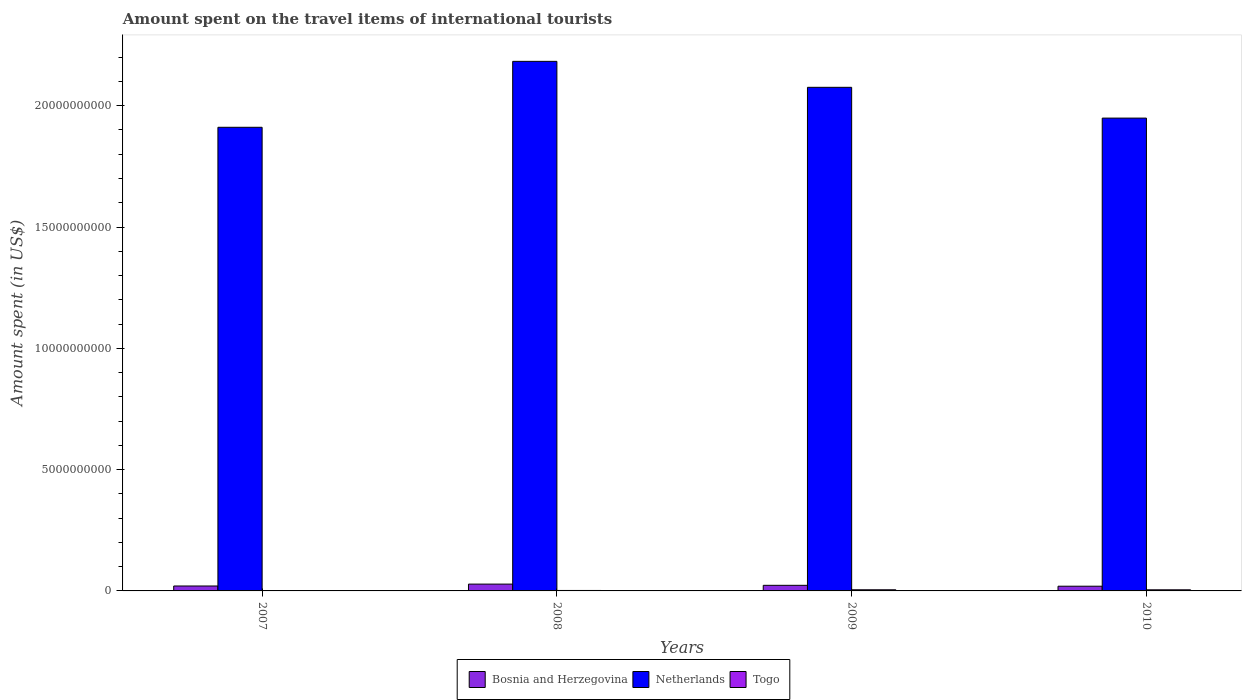How many different coloured bars are there?
Offer a terse response. 3. How many groups of bars are there?
Your answer should be compact. 4. Are the number of bars per tick equal to the number of legend labels?
Your answer should be compact. Yes. Are the number of bars on each tick of the X-axis equal?
Provide a short and direct response. Yes. How many bars are there on the 2nd tick from the right?
Make the answer very short. 3. What is the label of the 2nd group of bars from the left?
Your answer should be very brief. 2008. What is the amount spent on the travel items of international tourists in Bosnia and Herzegovina in 2008?
Your answer should be compact. 2.81e+08. Across all years, what is the maximum amount spent on the travel items of international tourists in Netherlands?
Your response must be concise. 2.18e+1. Across all years, what is the minimum amount spent on the travel items of international tourists in Netherlands?
Provide a succinct answer. 1.91e+1. In which year was the amount spent on the travel items of international tourists in Netherlands maximum?
Offer a very short reply. 2008. What is the total amount spent on the travel items of international tourists in Netherlands in the graph?
Offer a very short reply. 8.12e+1. What is the difference between the amount spent on the travel items of international tourists in Netherlands in 2007 and that in 2009?
Your answer should be very brief. -1.65e+09. What is the difference between the amount spent on the travel items of international tourists in Netherlands in 2007 and the amount spent on the travel items of international tourists in Bosnia and Herzegovina in 2010?
Offer a very short reply. 1.89e+1. What is the average amount spent on the travel items of international tourists in Bosnia and Herzegovina per year?
Provide a succinct answer. 2.27e+08. In the year 2010, what is the difference between the amount spent on the travel items of international tourists in Togo and amount spent on the travel items of international tourists in Netherlands?
Offer a terse response. -1.94e+1. What is the ratio of the amount spent on the travel items of international tourists in Togo in 2009 to that in 2010?
Provide a short and direct response. 1.02. Is the difference between the amount spent on the travel items of international tourists in Togo in 2007 and 2009 greater than the difference between the amount spent on the travel items of international tourists in Netherlands in 2007 and 2009?
Your answer should be very brief. Yes. What is the difference between the highest and the second highest amount spent on the travel items of international tourists in Netherlands?
Offer a terse response. 1.07e+09. What is the difference between the highest and the lowest amount spent on the travel items of international tourists in Bosnia and Herzegovina?
Offer a terse response. 8.70e+07. What does the 3rd bar from the left in 2010 represents?
Your answer should be compact. Togo. What does the 1st bar from the right in 2008 represents?
Offer a terse response. Togo. Is it the case that in every year, the sum of the amount spent on the travel items of international tourists in Togo and amount spent on the travel items of international tourists in Bosnia and Herzegovina is greater than the amount spent on the travel items of international tourists in Netherlands?
Ensure brevity in your answer.  No. How many bars are there?
Give a very brief answer. 12. Are all the bars in the graph horizontal?
Make the answer very short. No. What is the difference between two consecutive major ticks on the Y-axis?
Make the answer very short. 5.00e+09. Where does the legend appear in the graph?
Give a very brief answer. Bottom center. How many legend labels are there?
Provide a succinct answer. 3. How are the legend labels stacked?
Offer a terse response. Horizontal. What is the title of the graph?
Ensure brevity in your answer.  Amount spent on the travel items of international tourists. Does "Vanuatu" appear as one of the legend labels in the graph?
Ensure brevity in your answer.  No. What is the label or title of the Y-axis?
Offer a terse response. Amount spent (in US$). What is the Amount spent (in US$) in Bosnia and Herzegovina in 2007?
Make the answer very short. 2.03e+08. What is the Amount spent (in US$) of Netherlands in 2007?
Your answer should be compact. 1.91e+1. What is the Amount spent (in US$) of Togo in 2007?
Make the answer very short. 1.70e+07. What is the Amount spent (in US$) of Bosnia and Herzegovina in 2008?
Ensure brevity in your answer.  2.81e+08. What is the Amount spent (in US$) in Netherlands in 2008?
Provide a short and direct response. 2.18e+1. What is the Amount spent (in US$) of Togo in 2008?
Offer a very short reply. 1.90e+07. What is the Amount spent (in US$) in Bosnia and Herzegovina in 2009?
Your response must be concise. 2.31e+08. What is the Amount spent (in US$) in Netherlands in 2009?
Your answer should be very brief. 2.08e+1. What is the Amount spent (in US$) in Togo in 2009?
Keep it short and to the point. 4.70e+07. What is the Amount spent (in US$) in Bosnia and Herzegovina in 2010?
Your response must be concise. 1.94e+08. What is the Amount spent (in US$) in Netherlands in 2010?
Keep it short and to the point. 1.95e+1. What is the Amount spent (in US$) in Togo in 2010?
Give a very brief answer. 4.60e+07. Across all years, what is the maximum Amount spent (in US$) in Bosnia and Herzegovina?
Your response must be concise. 2.81e+08. Across all years, what is the maximum Amount spent (in US$) of Netherlands?
Offer a terse response. 2.18e+1. Across all years, what is the maximum Amount spent (in US$) of Togo?
Give a very brief answer. 4.70e+07. Across all years, what is the minimum Amount spent (in US$) of Bosnia and Herzegovina?
Your answer should be very brief. 1.94e+08. Across all years, what is the minimum Amount spent (in US$) in Netherlands?
Your answer should be compact. 1.91e+1. Across all years, what is the minimum Amount spent (in US$) of Togo?
Your answer should be very brief. 1.70e+07. What is the total Amount spent (in US$) in Bosnia and Herzegovina in the graph?
Ensure brevity in your answer.  9.09e+08. What is the total Amount spent (in US$) of Netherlands in the graph?
Offer a very short reply. 8.12e+1. What is the total Amount spent (in US$) of Togo in the graph?
Offer a very short reply. 1.29e+08. What is the difference between the Amount spent (in US$) in Bosnia and Herzegovina in 2007 and that in 2008?
Keep it short and to the point. -7.80e+07. What is the difference between the Amount spent (in US$) of Netherlands in 2007 and that in 2008?
Offer a terse response. -2.72e+09. What is the difference between the Amount spent (in US$) in Togo in 2007 and that in 2008?
Ensure brevity in your answer.  -2.00e+06. What is the difference between the Amount spent (in US$) of Bosnia and Herzegovina in 2007 and that in 2009?
Offer a very short reply. -2.80e+07. What is the difference between the Amount spent (in US$) in Netherlands in 2007 and that in 2009?
Ensure brevity in your answer.  -1.65e+09. What is the difference between the Amount spent (in US$) in Togo in 2007 and that in 2009?
Give a very brief answer. -3.00e+07. What is the difference between the Amount spent (in US$) of Bosnia and Herzegovina in 2007 and that in 2010?
Provide a succinct answer. 9.00e+06. What is the difference between the Amount spent (in US$) of Netherlands in 2007 and that in 2010?
Ensure brevity in your answer.  -3.79e+08. What is the difference between the Amount spent (in US$) in Togo in 2007 and that in 2010?
Your answer should be compact. -2.90e+07. What is the difference between the Amount spent (in US$) of Bosnia and Herzegovina in 2008 and that in 2009?
Make the answer very short. 5.00e+07. What is the difference between the Amount spent (in US$) in Netherlands in 2008 and that in 2009?
Give a very brief answer. 1.07e+09. What is the difference between the Amount spent (in US$) of Togo in 2008 and that in 2009?
Your answer should be very brief. -2.80e+07. What is the difference between the Amount spent (in US$) of Bosnia and Herzegovina in 2008 and that in 2010?
Your answer should be very brief. 8.70e+07. What is the difference between the Amount spent (in US$) in Netherlands in 2008 and that in 2010?
Your answer should be compact. 2.34e+09. What is the difference between the Amount spent (in US$) of Togo in 2008 and that in 2010?
Keep it short and to the point. -2.70e+07. What is the difference between the Amount spent (in US$) of Bosnia and Herzegovina in 2009 and that in 2010?
Give a very brief answer. 3.70e+07. What is the difference between the Amount spent (in US$) of Netherlands in 2009 and that in 2010?
Keep it short and to the point. 1.27e+09. What is the difference between the Amount spent (in US$) of Togo in 2009 and that in 2010?
Your response must be concise. 1.00e+06. What is the difference between the Amount spent (in US$) of Bosnia and Herzegovina in 2007 and the Amount spent (in US$) of Netherlands in 2008?
Keep it short and to the point. -2.16e+1. What is the difference between the Amount spent (in US$) of Bosnia and Herzegovina in 2007 and the Amount spent (in US$) of Togo in 2008?
Your response must be concise. 1.84e+08. What is the difference between the Amount spent (in US$) of Netherlands in 2007 and the Amount spent (in US$) of Togo in 2008?
Offer a very short reply. 1.91e+1. What is the difference between the Amount spent (in US$) in Bosnia and Herzegovina in 2007 and the Amount spent (in US$) in Netherlands in 2009?
Provide a succinct answer. -2.06e+1. What is the difference between the Amount spent (in US$) of Bosnia and Herzegovina in 2007 and the Amount spent (in US$) of Togo in 2009?
Provide a short and direct response. 1.56e+08. What is the difference between the Amount spent (in US$) in Netherlands in 2007 and the Amount spent (in US$) in Togo in 2009?
Provide a short and direct response. 1.91e+1. What is the difference between the Amount spent (in US$) of Bosnia and Herzegovina in 2007 and the Amount spent (in US$) of Netherlands in 2010?
Your response must be concise. -1.93e+1. What is the difference between the Amount spent (in US$) in Bosnia and Herzegovina in 2007 and the Amount spent (in US$) in Togo in 2010?
Your answer should be very brief. 1.57e+08. What is the difference between the Amount spent (in US$) of Netherlands in 2007 and the Amount spent (in US$) of Togo in 2010?
Offer a terse response. 1.91e+1. What is the difference between the Amount spent (in US$) in Bosnia and Herzegovina in 2008 and the Amount spent (in US$) in Netherlands in 2009?
Make the answer very short. -2.05e+1. What is the difference between the Amount spent (in US$) of Bosnia and Herzegovina in 2008 and the Amount spent (in US$) of Togo in 2009?
Give a very brief answer. 2.34e+08. What is the difference between the Amount spent (in US$) of Netherlands in 2008 and the Amount spent (in US$) of Togo in 2009?
Your response must be concise. 2.18e+1. What is the difference between the Amount spent (in US$) of Bosnia and Herzegovina in 2008 and the Amount spent (in US$) of Netherlands in 2010?
Keep it short and to the point. -1.92e+1. What is the difference between the Amount spent (in US$) of Bosnia and Herzegovina in 2008 and the Amount spent (in US$) of Togo in 2010?
Offer a very short reply. 2.35e+08. What is the difference between the Amount spent (in US$) in Netherlands in 2008 and the Amount spent (in US$) in Togo in 2010?
Make the answer very short. 2.18e+1. What is the difference between the Amount spent (in US$) of Bosnia and Herzegovina in 2009 and the Amount spent (in US$) of Netherlands in 2010?
Your answer should be compact. -1.93e+1. What is the difference between the Amount spent (in US$) of Bosnia and Herzegovina in 2009 and the Amount spent (in US$) of Togo in 2010?
Offer a terse response. 1.85e+08. What is the difference between the Amount spent (in US$) of Netherlands in 2009 and the Amount spent (in US$) of Togo in 2010?
Keep it short and to the point. 2.07e+1. What is the average Amount spent (in US$) of Bosnia and Herzegovina per year?
Ensure brevity in your answer.  2.27e+08. What is the average Amount spent (in US$) in Netherlands per year?
Provide a short and direct response. 2.03e+1. What is the average Amount spent (in US$) of Togo per year?
Provide a short and direct response. 3.22e+07. In the year 2007, what is the difference between the Amount spent (in US$) in Bosnia and Herzegovina and Amount spent (in US$) in Netherlands?
Give a very brief answer. -1.89e+1. In the year 2007, what is the difference between the Amount spent (in US$) in Bosnia and Herzegovina and Amount spent (in US$) in Togo?
Make the answer very short. 1.86e+08. In the year 2007, what is the difference between the Amount spent (in US$) in Netherlands and Amount spent (in US$) in Togo?
Offer a very short reply. 1.91e+1. In the year 2008, what is the difference between the Amount spent (in US$) in Bosnia and Herzegovina and Amount spent (in US$) in Netherlands?
Your answer should be compact. -2.15e+1. In the year 2008, what is the difference between the Amount spent (in US$) in Bosnia and Herzegovina and Amount spent (in US$) in Togo?
Provide a succinct answer. 2.62e+08. In the year 2008, what is the difference between the Amount spent (in US$) in Netherlands and Amount spent (in US$) in Togo?
Make the answer very short. 2.18e+1. In the year 2009, what is the difference between the Amount spent (in US$) of Bosnia and Herzegovina and Amount spent (in US$) of Netherlands?
Make the answer very short. -2.05e+1. In the year 2009, what is the difference between the Amount spent (in US$) in Bosnia and Herzegovina and Amount spent (in US$) in Togo?
Give a very brief answer. 1.84e+08. In the year 2009, what is the difference between the Amount spent (in US$) of Netherlands and Amount spent (in US$) of Togo?
Your answer should be very brief. 2.07e+1. In the year 2010, what is the difference between the Amount spent (in US$) in Bosnia and Herzegovina and Amount spent (in US$) in Netherlands?
Your answer should be very brief. -1.93e+1. In the year 2010, what is the difference between the Amount spent (in US$) of Bosnia and Herzegovina and Amount spent (in US$) of Togo?
Provide a short and direct response. 1.48e+08. In the year 2010, what is the difference between the Amount spent (in US$) in Netherlands and Amount spent (in US$) in Togo?
Provide a succinct answer. 1.94e+1. What is the ratio of the Amount spent (in US$) of Bosnia and Herzegovina in 2007 to that in 2008?
Make the answer very short. 0.72. What is the ratio of the Amount spent (in US$) in Netherlands in 2007 to that in 2008?
Provide a succinct answer. 0.88. What is the ratio of the Amount spent (in US$) of Togo in 2007 to that in 2008?
Your answer should be compact. 0.89. What is the ratio of the Amount spent (in US$) of Bosnia and Herzegovina in 2007 to that in 2009?
Your response must be concise. 0.88. What is the ratio of the Amount spent (in US$) in Netherlands in 2007 to that in 2009?
Offer a very short reply. 0.92. What is the ratio of the Amount spent (in US$) of Togo in 2007 to that in 2009?
Ensure brevity in your answer.  0.36. What is the ratio of the Amount spent (in US$) in Bosnia and Herzegovina in 2007 to that in 2010?
Keep it short and to the point. 1.05. What is the ratio of the Amount spent (in US$) in Netherlands in 2007 to that in 2010?
Offer a terse response. 0.98. What is the ratio of the Amount spent (in US$) of Togo in 2007 to that in 2010?
Provide a succinct answer. 0.37. What is the ratio of the Amount spent (in US$) of Bosnia and Herzegovina in 2008 to that in 2009?
Offer a very short reply. 1.22. What is the ratio of the Amount spent (in US$) in Netherlands in 2008 to that in 2009?
Keep it short and to the point. 1.05. What is the ratio of the Amount spent (in US$) of Togo in 2008 to that in 2009?
Ensure brevity in your answer.  0.4. What is the ratio of the Amount spent (in US$) of Bosnia and Herzegovina in 2008 to that in 2010?
Make the answer very short. 1.45. What is the ratio of the Amount spent (in US$) in Netherlands in 2008 to that in 2010?
Your answer should be very brief. 1.12. What is the ratio of the Amount spent (in US$) in Togo in 2008 to that in 2010?
Your answer should be compact. 0.41. What is the ratio of the Amount spent (in US$) in Bosnia and Herzegovina in 2009 to that in 2010?
Your answer should be compact. 1.19. What is the ratio of the Amount spent (in US$) in Netherlands in 2009 to that in 2010?
Give a very brief answer. 1.07. What is the ratio of the Amount spent (in US$) in Togo in 2009 to that in 2010?
Your answer should be compact. 1.02. What is the difference between the highest and the second highest Amount spent (in US$) of Netherlands?
Give a very brief answer. 1.07e+09. What is the difference between the highest and the second highest Amount spent (in US$) of Togo?
Provide a short and direct response. 1.00e+06. What is the difference between the highest and the lowest Amount spent (in US$) of Bosnia and Herzegovina?
Your response must be concise. 8.70e+07. What is the difference between the highest and the lowest Amount spent (in US$) in Netherlands?
Provide a succinct answer. 2.72e+09. What is the difference between the highest and the lowest Amount spent (in US$) in Togo?
Provide a short and direct response. 3.00e+07. 